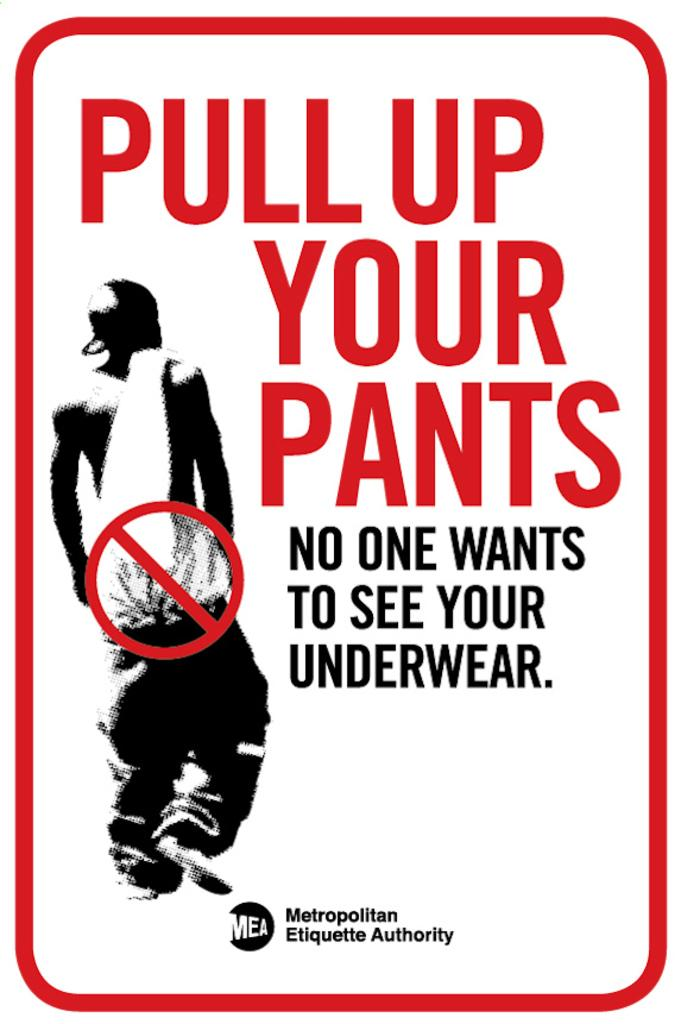<image>
Relay a brief, clear account of the picture shown. A sign with pull up your pants written on it. 